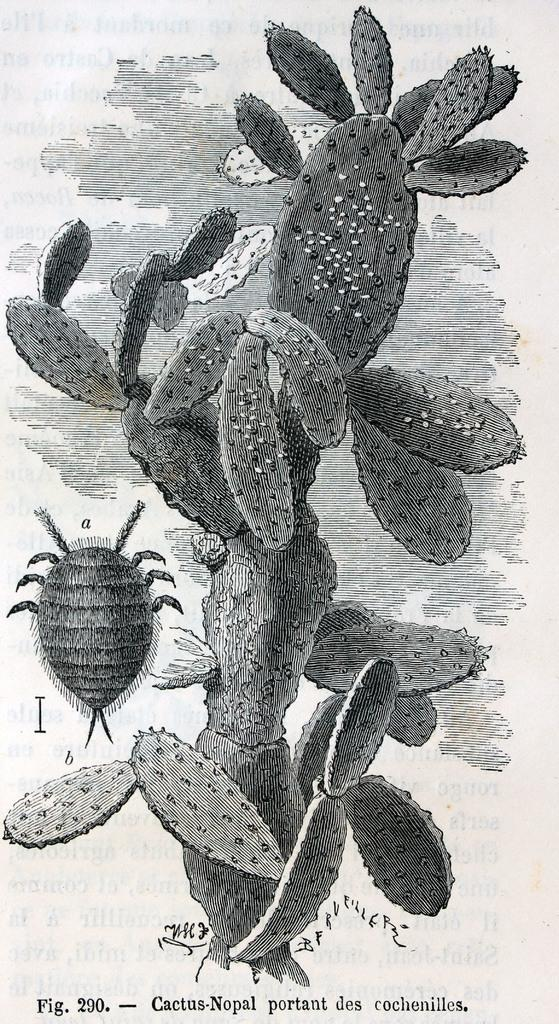What type of plant is in the image? There is a cactus plant in the image. Are there any animals or insects visible in the image? Yes, there is an insect in the image. What is the condition of the steel in the image? There is no steel present in the image. Does the sister appear in the image? There is no mention of a sister in the provided facts, so it cannot be determined if she appears in the image. 